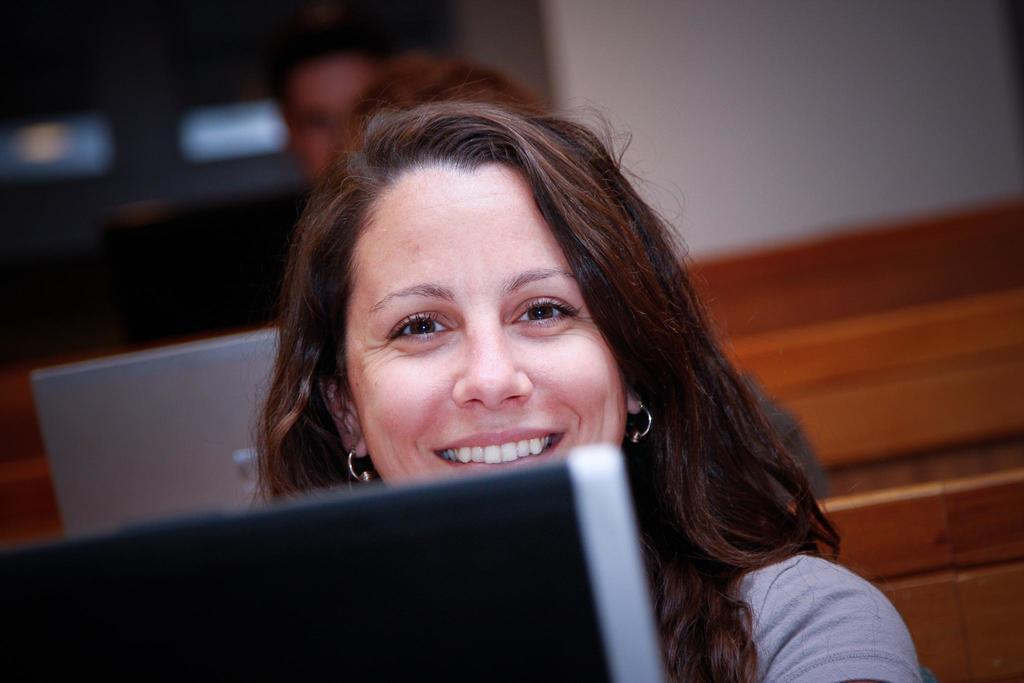What is the woman in the image doing? The woman is sitting and smiling in the image. What can be seen in the foreground of the image? There is a device in the foreground of the image. Can you describe the person at the back of the image? There is a person at the back of the image, but no specific details about them are provided. What is present at the back of the image along with the person? There is another device at the back of the image. What is visible in the background of the image? There is a wall visible in the image. What type of bait is being used to catch the snake in the image? There is no snake or bait present in the image. What is the bucket being used for in the image? There is no bucket present in the image. 